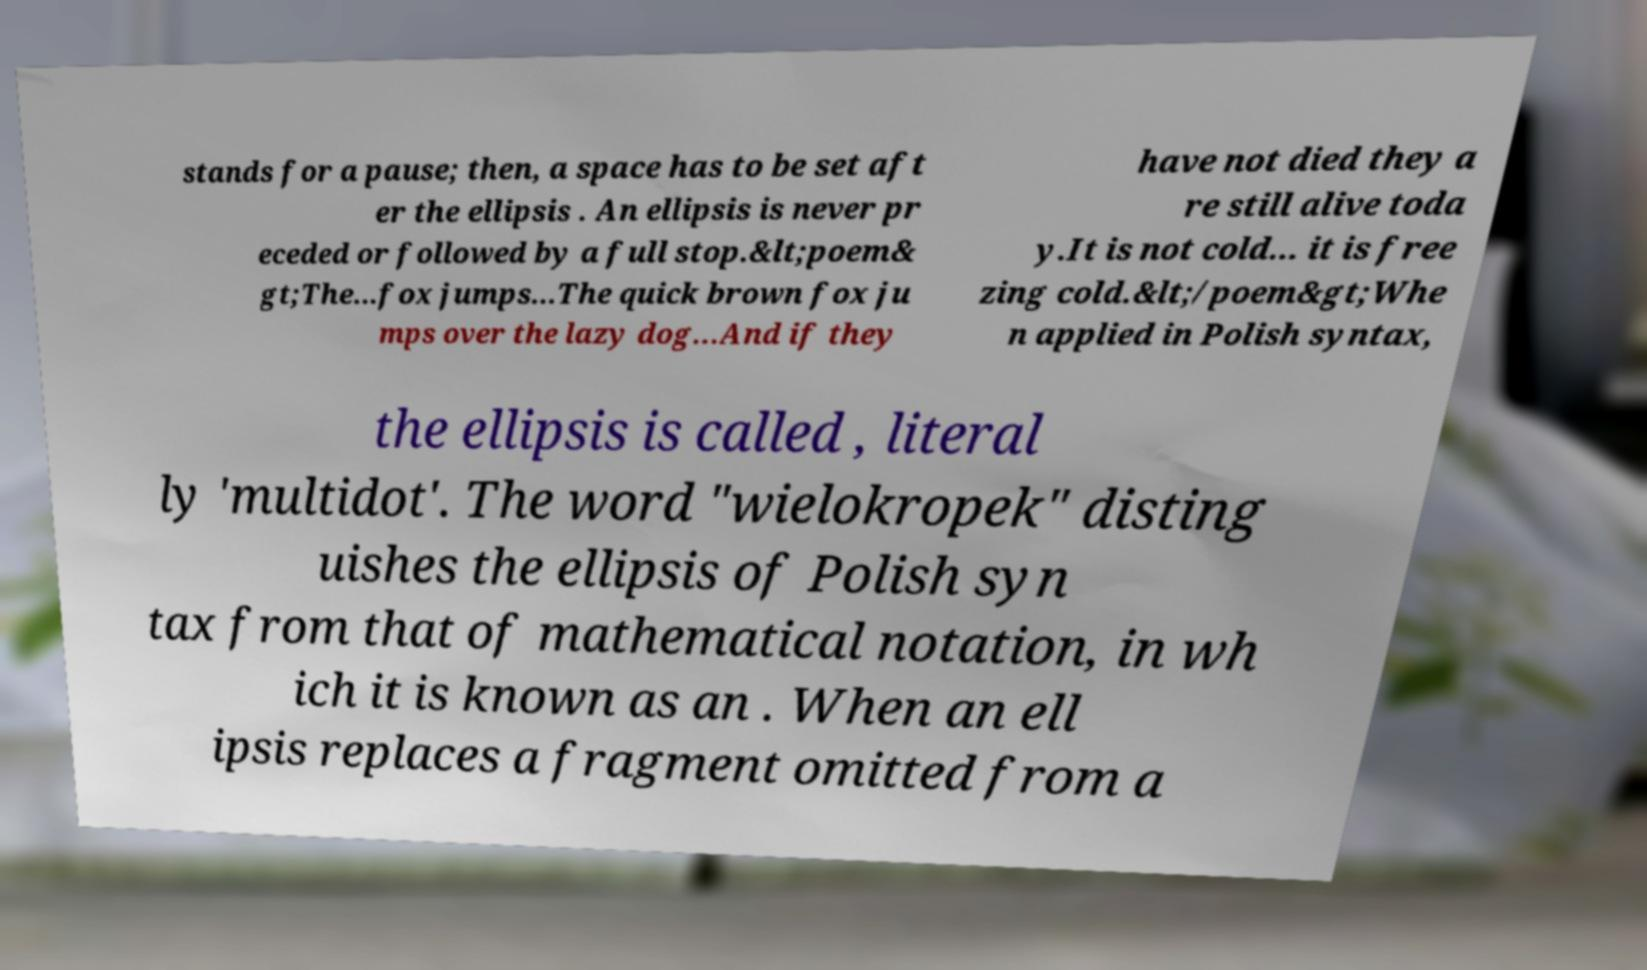For documentation purposes, I need the text within this image transcribed. Could you provide that? stands for a pause; then, a space has to be set aft er the ellipsis . An ellipsis is never pr eceded or followed by a full stop.&lt;poem& gt;The...fox jumps...The quick brown fox ju mps over the lazy dog...And if they have not died they a re still alive toda y.It is not cold... it is free zing cold.&lt;/poem&gt;Whe n applied in Polish syntax, the ellipsis is called , literal ly 'multidot'. The word "wielokropek" disting uishes the ellipsis of Polish syn tax from that of mathematical notation, in wh ich it is known as an . When an ell ipsis replaces a fragment omitted from a 